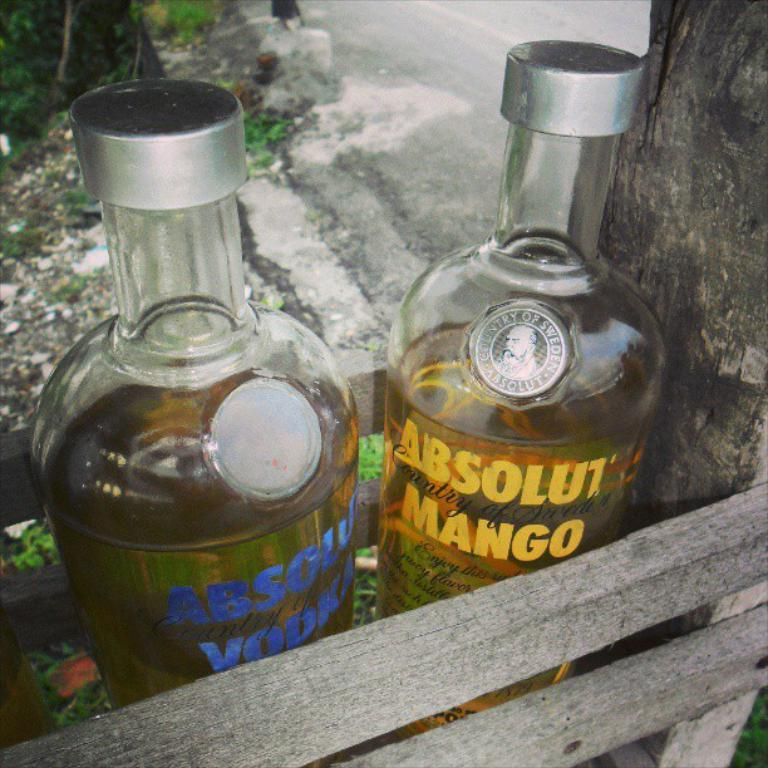<image>
Render a clear and concise summary of the photo. Two bottles of Absolut Vodka, one of which is mango flavoured. 